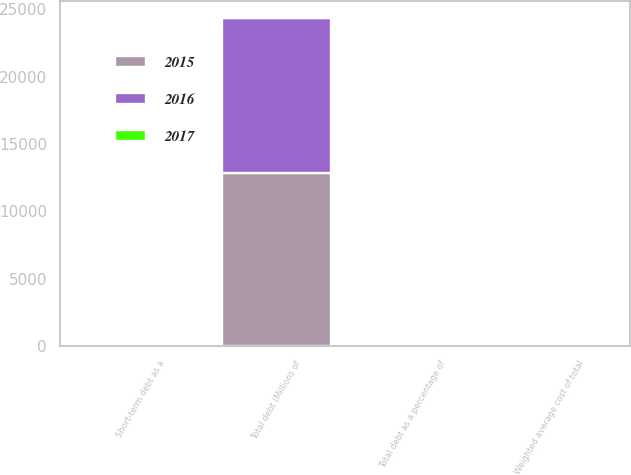Convert chart. <chart><loc_0><loc_0><loc_500><loc_500><stacked_bar_chart><ecel><fcel>Total debt (Millions of<fcel>Short-term debt as a<fcel>Weighted average cost of total<fcel>Total debt as a percentage of<nl><fcel>2017<fcel>11.3<fcel>1.1<fcel>3.3<fcel>57.5<nl><fcel>2016<fcel>11551<fcel>8.7<fcel>3.6<fcel>57.2<nl><fcel>2015<fcel>12822<fcel>11.3<fcel>3.3<fcel>59.4<nl></chart> 